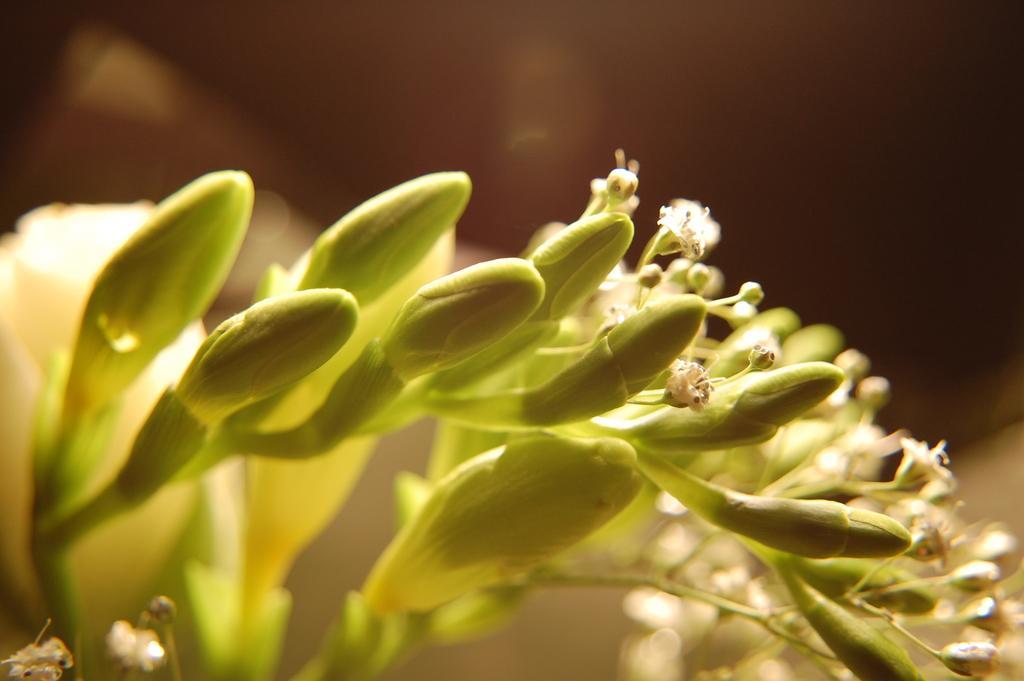In one or two sentences, can you explain what this image depicts? In this image I can see flowering plants and a dark color. This image is taken may be during night. 